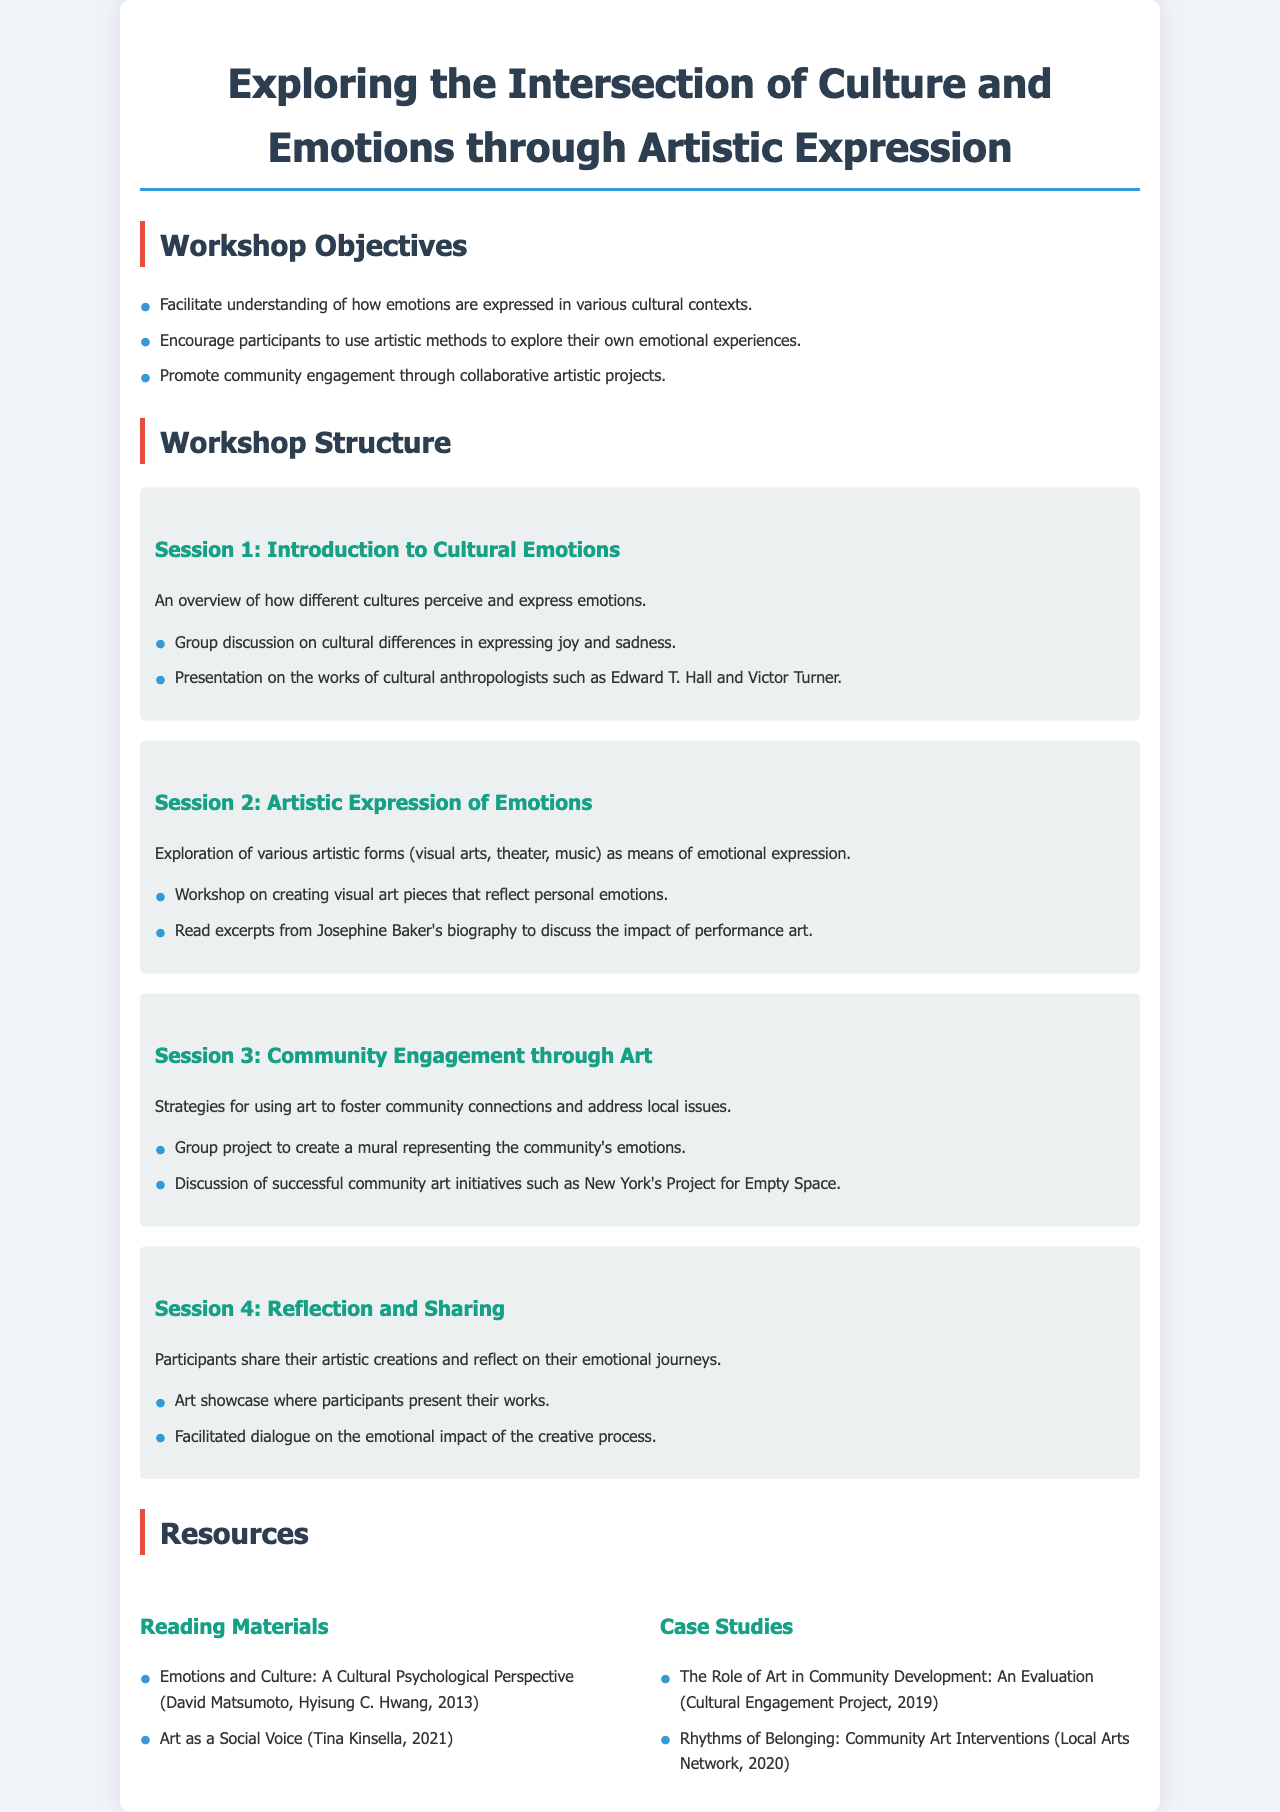What are the workshop objectives? The workshop objectives are three specific goals outlined in the document: understanding emotions in cultural contexts, using artistic methods for emotional exploration, and promoting community engagement through art.
Answer: Facilitate understanding of how emotions are expressed in various cultural contexts, encourage participants to use artistic methods to explore their own emotional experiences, promote community engagement through collaborative artistic projects How many sessions are described in the workshop structure? The workshop structure lists four distinct sessions.
Answer: 4 What is the title of Session 2? The title of Session 2 is stated distinctly, focusing on the artistic aspect of emotions.
Answer: Artistic Expression of Emotions Which cultural anthropologists are mentioned in Session 1? The document references two specific cultural anthropologists, providing insight into the academic background related to cultural emotions.
Answer: Edward T. Hall and Victor Turner What community art initiative is discussed in Session 3? The document provides a specific name of a community art initiative to illustrate successful community engagement.
Answer: New York's Project for Empty Space What is one of the reading materials listed as a resource? One specific reading material is highlighted in the resources section, reflecting the themes of the workshop.
Answer: Emotions and Culture: A Cultural Psychological Perspective (David Matsumoto, Hyisung C. Hwang, 2013) 